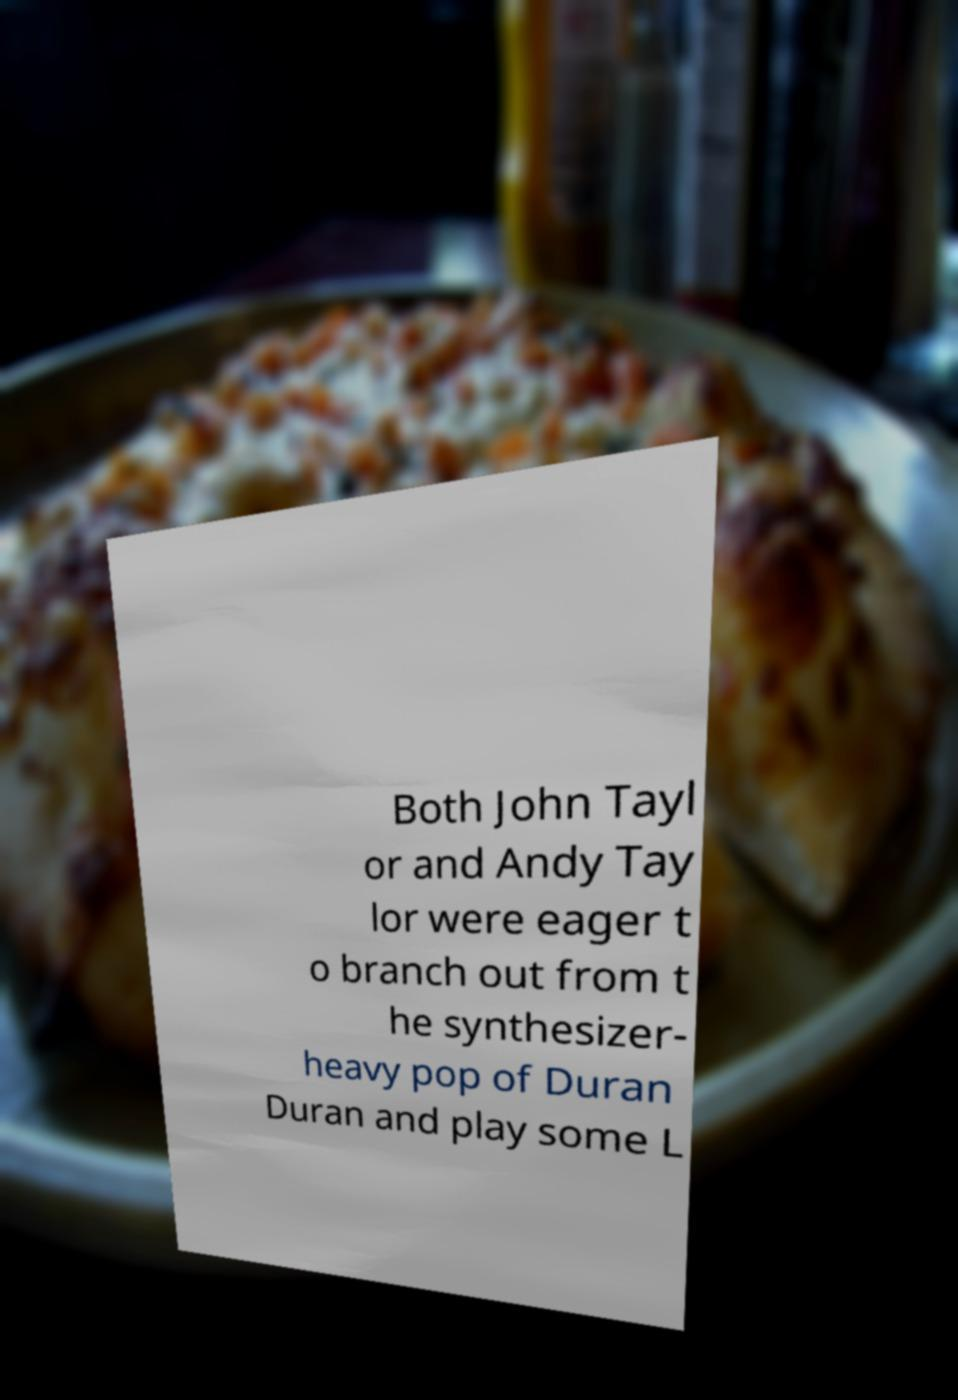Please read and relay the text visible in this image. What does it say? Both John Tayl or and Andy Tay lor were eager t o branch out from t he synthesizer- heavy pop of Duran Duran and play some L 